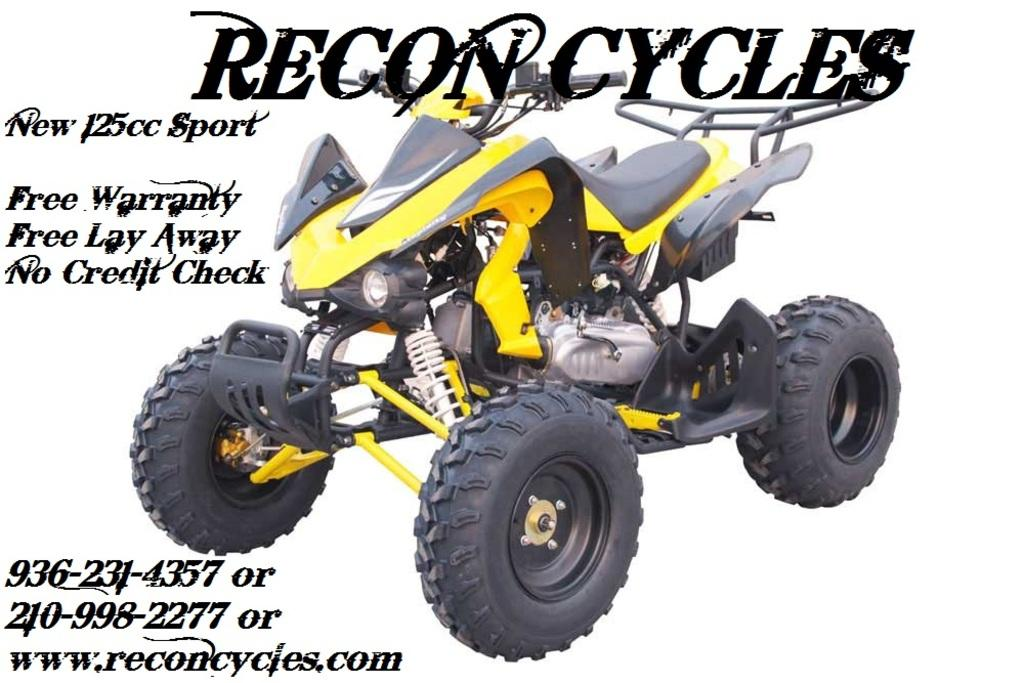What is present in the image? There is a poster in the image. What can be seen on the poster? The poster has an image of a vehicle and texts. What is the color of the background in the vehicle image? The background of the vehicle image is white in color. What type of food is being served for lunch on the poster? There is no mention of food or lunch in the image, as it features a poster with an image of a vehicle and texts. 